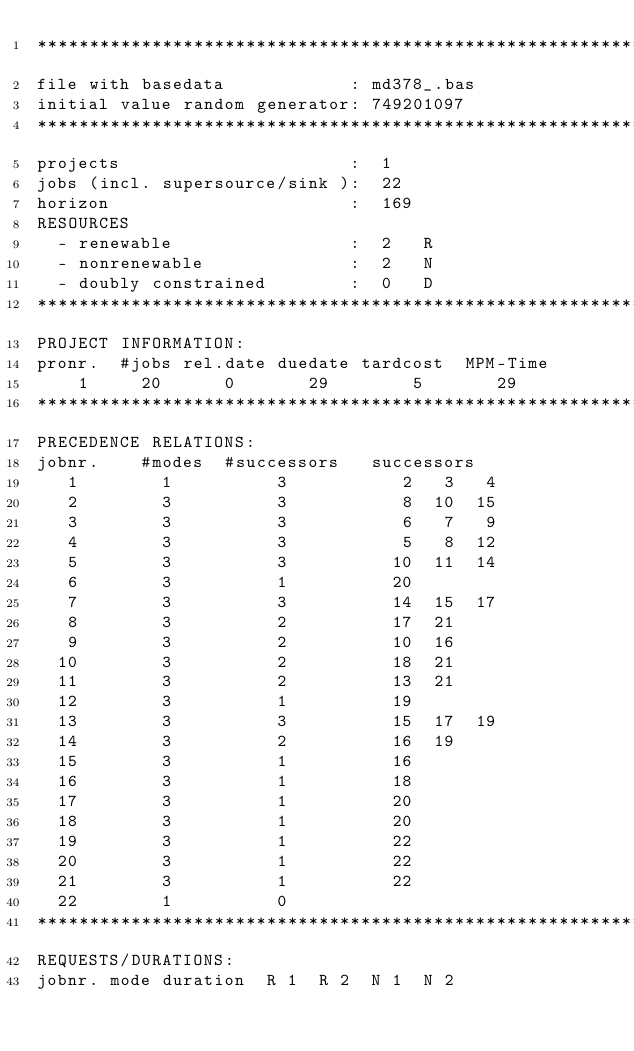<code> <loc_0><loc_0><loc_500><loc_500><_ObjectiveC_>************************************************************************
file with basedata            : md378_.bas
initial value random generator: 749201097
************************************************************************
projects                      :  1
jobs (incl. supersource/sink ):  22
horizon                       :  169
RESOURCES
  - renewable                 :  2   R
  - nonrenewable              :  2   N
  - doubly constrained        :  0   D
************************************************************************
PROJECT INFORMATION:
pronr.  #jobs rel.date duedate tardcost  MPM-Time
    1     20      0       29        5       29
************************************************************************
PRECEDENCE RELATIONS:
jobnr.    #modes  #successors   successors
   1        1          3           2   3   4
   2        3          3           8  10  15
   3        3          3           6   7   9
   4        3          3           5   8  12
   5        3          3          10  11  14
   6        3          1          20
   7        3          3          14  15  17
   8        3          2          17  21
   9        3          2          10  16
  10        3          2          18  21
  11        3          2          13  21
  12        3          1          19
  13        3          3          15  17  19
  14        3          2          16  19
  15        3          1          16
  16        3          1          18
  17        3          1          20
  18        3          1          20
  19        3          1          22
  20        3          1          22
  21        3          1          22
  22        1          0        
************************************************************************
REQUESTS/DURATIONS:
jobnr. mode duration  R 1  R 2  N 1  N 2</code> 